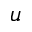Convert formula to latex. <formula><loc_0><loc_0><loc_500><loc_500>u</formula> 